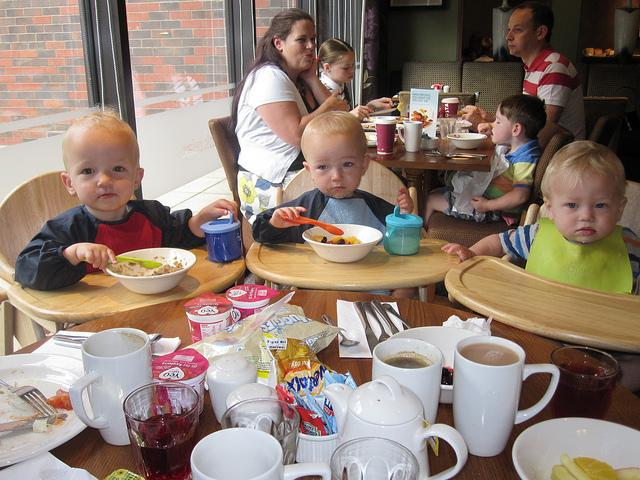Where are these 3 kids most likely from? same mother 